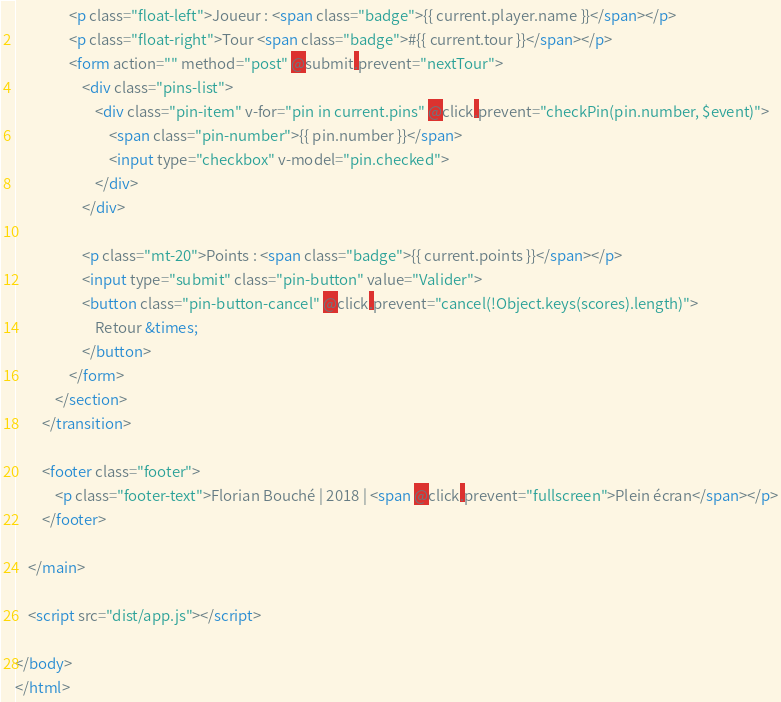Convert code to text. <code><loc_0><loc_0><loc_500><loc_500><_HTML_>                <p class="float-left">Joueur : <span class="badge">{{ current.player.name }}</span></p>
                <p class="float-right">Tour <span class="badge">#{{ current.tour }}</span></p>
                <form action="" method="post" @submit.prevent="nextTour">
                    <div class="pins-list">
                        <div class="pin-item" v-for="pin in current.pins" @click.prevent="checkPin(pin.number, $event)">
                            <span class="pin-number">{{ pin.number }}</span>
                            <input type="checkbox" v-model="pin.checked">
                        </div>
                    </div>

                    <p class="mt-20">Points : <span class="badge">{{ current.points }}</span></p>
                    <input type="submit" class="pin-button" value="Valider">
                    <button class="pin-button-cancel" @click.prevent="cancel(!Object.keys(scores).length)">
                        Retour &times;
                    </button>
                </form>
            </section>
        </transition>

        <footer class="footer">
            <p class="footer-text">Florian Bouché | 2018 | <span @click.prevent="fullscreen">Plein écran</span></p>
        </footer>

    </main>

    <script src="dist/app.js"></script>

</body>
</html></code> 